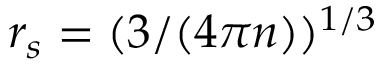Convert formula to latex. <formula><loc_0><loc_0><loc_500><loc_500>r _ { s } = ( 3 / ( 4 \pi n ) ) ^ { 1 / 3 }</formula> 